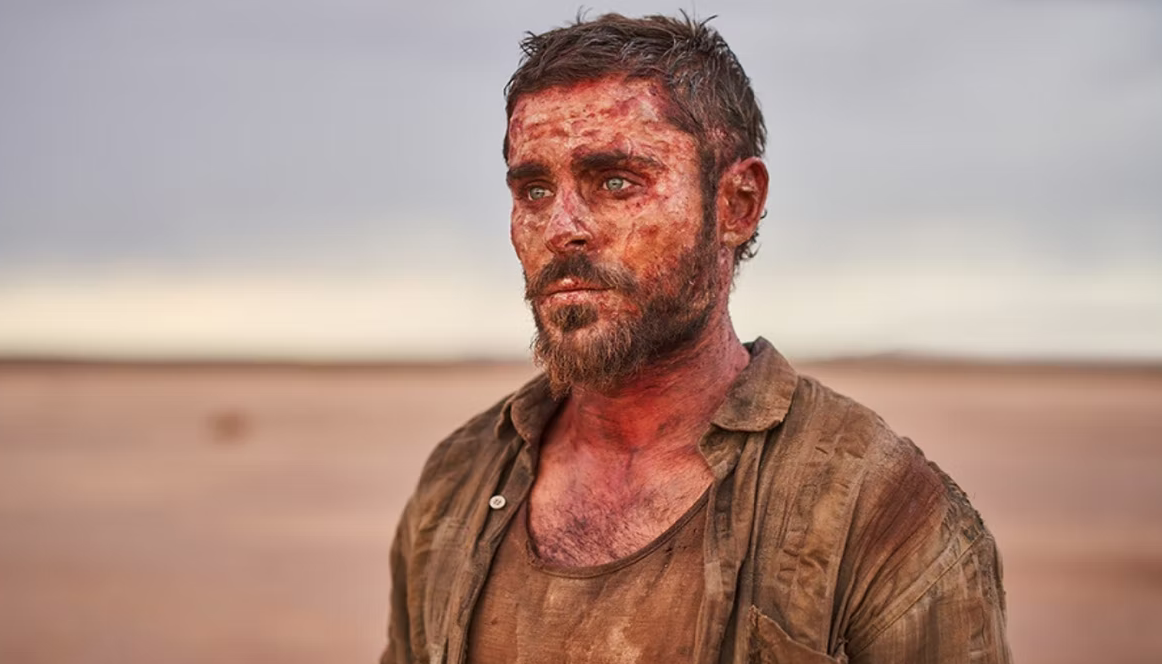What story does this image tell about the character and his situation? The image appears to tell a gripping story of survival and resilience. The man's appearance suggests he has endured significant hardship in a harsh, unforgiving environment. The dirt and blood on his face and clothes hint at physical confrontations or accidents, while his expression, marked by a mix of exhaustion and determination, indicates that he is not ready to give up despite the difficulties. The barren desert backdrop evokes a sense of isolation and struggle against the elements, suggesting that he might be on a solitary journey. His simple attire and rugged look add to the narrative of an ordinary individual thrust into extraordinary circumstances, fighting to survive against all odds. 